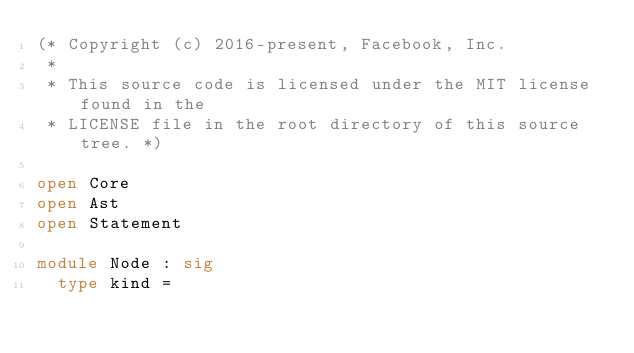<code> <loc_0><loc_0><loc_500><loc_500><_OCaml_>(* Copyright (c) 2016-present, Facebook, Inc.
 *
 * This source code is licensed under the MIT license found in the
 * LICENSE file in the root directory of this source tree. *)

open Core
open Ast
open Statement

module Node : sig
  type kind =</code> 